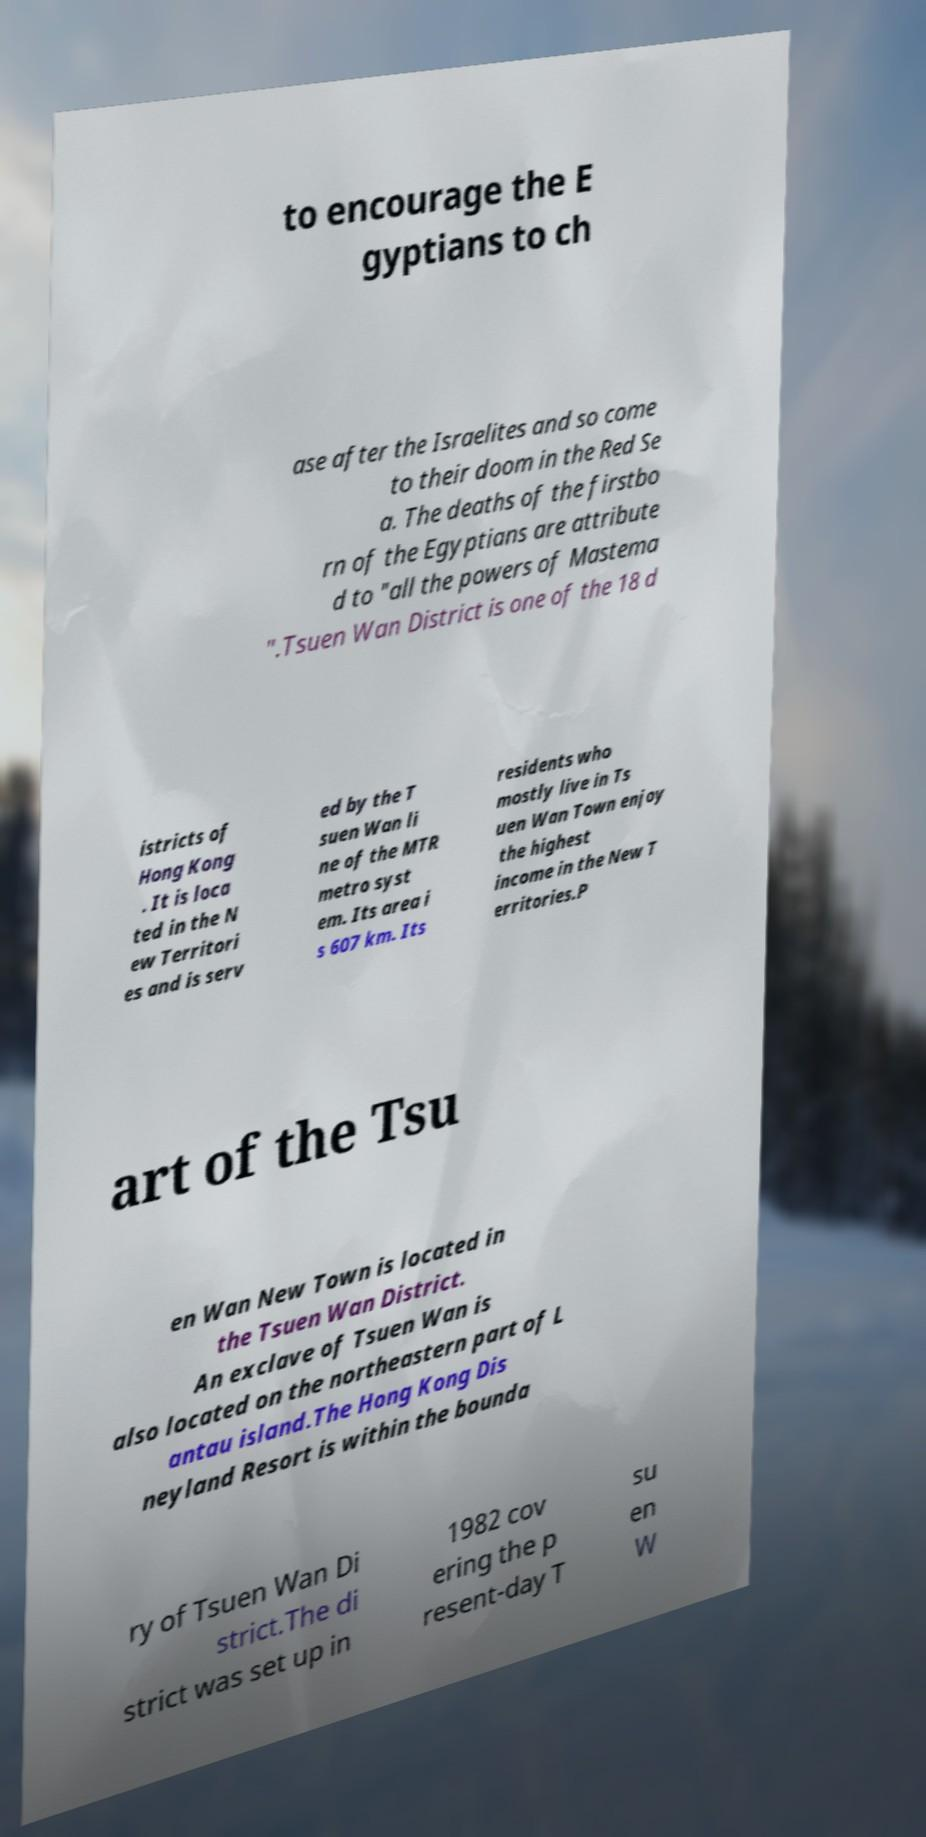There's text embedded in this image that I need extracted. Can you transcribe it verbatim? to encourage the E gyptians to ch ase after the Israelites and so come to their doom in the Red Se a. The deaths of the firstbo rn of the Egyptians are attribute d to "all the powers of Mastema ".Tsuen Wan District is one of the 18 d istricts of Hong Kong . It is loca ted in the N ew Territori es and is serv ed by the T suen Wan li ne of the MTR metro syst em. Its area i s 607 km. Its residents who mostly live in Ts uen Wan Town enjoy the highest income in the New T erritories.P art of the Tsu en Wan New Town is located in the Tsuen Wan District. An exclave of Tsuen Wan is also located on the northeastern part of L antau island.The Hong Kong Dis neyland Resort is within the bounda ry of Tsuen Wan Di strict.The di strict was set up in 1982 cov ering the p resent-day T su en W 